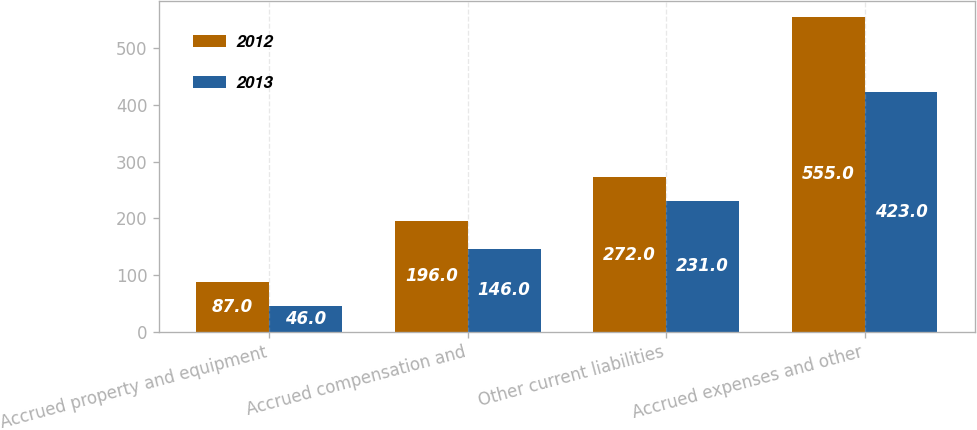<chart> <loc_0><loc_0><loc_500><loc_500><stacked_bar_chart><ecel><fcel>Accrued property and equipment<fcel>Accrued compensation and<fcel>Other current liabilities<fcel>Accrued expenses and other<nl><fcel>2012<fcel>87<fcel>196<fcel>272<fcel>555<nl><fcel>2013<fcel>46<fcel>146<fcel>231<fcel>423<nl></chart> 